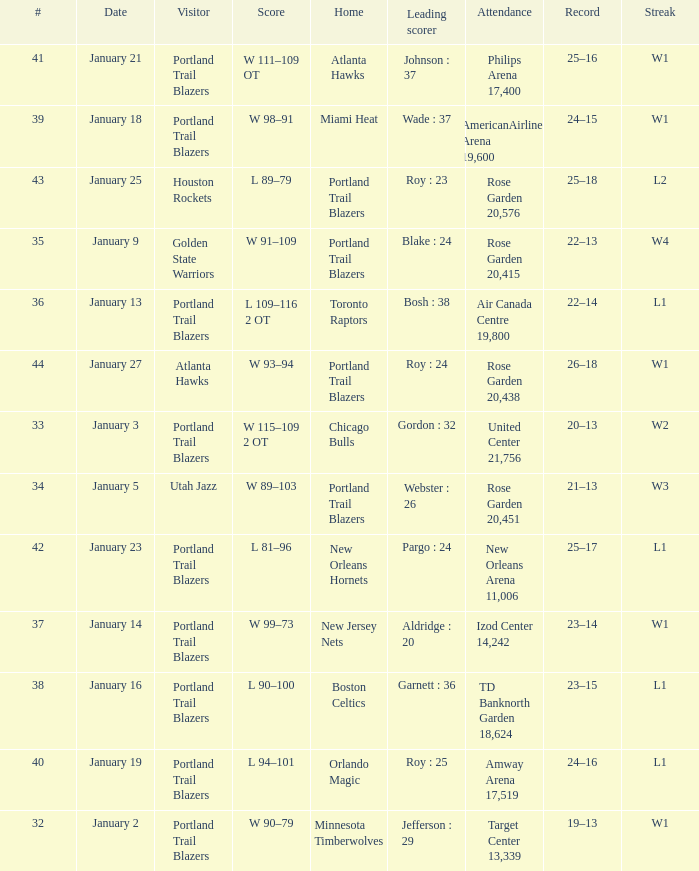What records have a score of l 109–116 2 ot 22–14. 